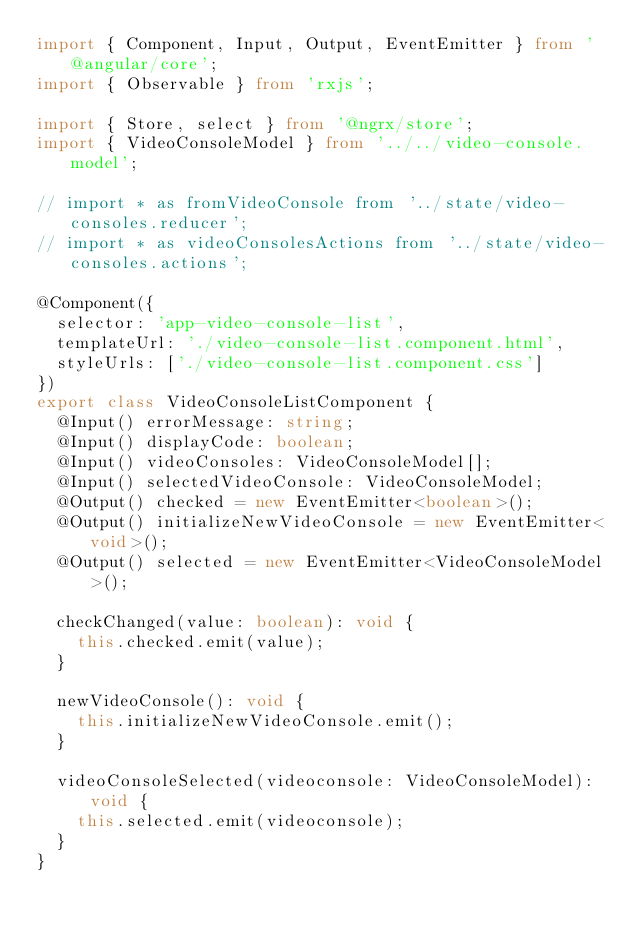Convert code to text. <code><loc_0><loc_0><loc_500><loc_500><_TypeScript_>import { Component, Input, Output, EventEmitter } from '@angular/core';
import { Observable } from 'rxjs';

import { Store, select } from '@ngrx/store';
import { VideoConsoleModel } from '../../video-console.model';

// import * as fromVideoConsole from '../state/video-consoles.reducer';
// import * as videoConsolesActions from '../state/video-consoles.actions';

@Component({
  selector: 'app-video-console-list',
  templateUrl: './video-console-list.component.html',
  styleUrls: ['./video-console-list.component.css']
})
export class VideoConsoleListComponent {
  @Input() errorMessage: string;
  @Input() displayCode: boolean;
  @Input() videoConsoles: VideoConsoleModel[];
  @Input() selectedVideoConsole: VideoConsoleModel;
  @Output() checked = new EventEmitter<boolean>();
  @Output() initializeNewVideoConsole = new EventEmitter<void>();
  @Output() selected = new EventEmitter<VideoConsoleModel>();

  checkChanged(value: boolean): void {
    this.checked.emit(value);
  }

  newVideoConsole(): void {
    this.initializeNewVideoConsole.emit();
  }

  videoConsoleSelected(videoconsole: VideoConsoleModel): void {
    this.selected.emit(videoconsole);
  }
}
</code> 